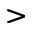<formula> <loc_0><loc_0><loc_500><loc_500>></formula> 